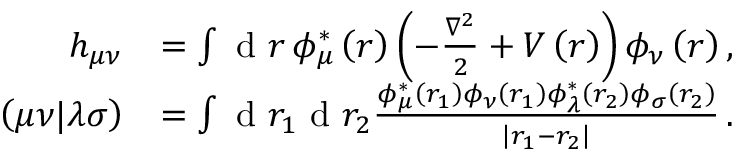<formula> <loc_0><loc_0><loc_500><loc_500>\begin{array} { r l } { h _ { \mu \nu } } & { = \int d r \, \phi _ { \mu } ^ { * } \left ( r \right ) \left ( - \frac { \nabla ^ { 2 } } { 2 } + V \left ( r \right ) \right ) \phi _ { \nu } \left ( r \right ) , } \\ { \left ( \mu \nu | \lambda \sigma \right ) } & { = \int d r _ { 1 } d r _ { 2 } \frac { \phi _ { \mu } ^ { * } \left ( r _ { 1 } \right ) \phi _ { \nu } \left ( r _ { 1 } \right ) \phi _ { \lambda } ^ { * } \left ( r _ { 2 } \right ) \phi _ { \sigma } \left ( r _ { 2 } \right ) } { \left | r _ { 1 } - r _ { 2 } \right | } \, . } \end{array}</formula> 